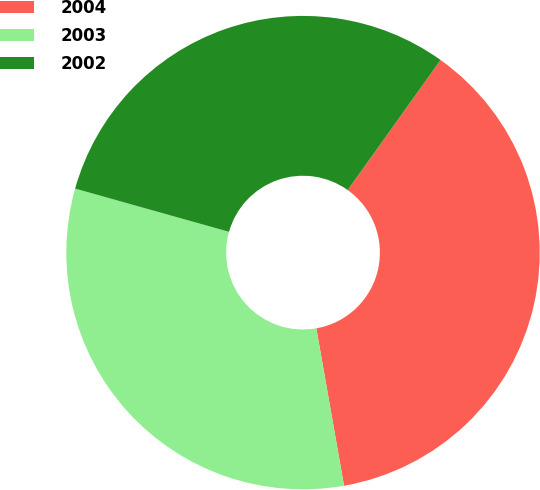<chart> <loc_0><loc_0><loc_500><loc_500><pie_chart><fcel>2004<fcel>2003<fcel>2002<nl><fcel>37.36%<fcel>32.13%<fcel>30.51%<nl></chart> 